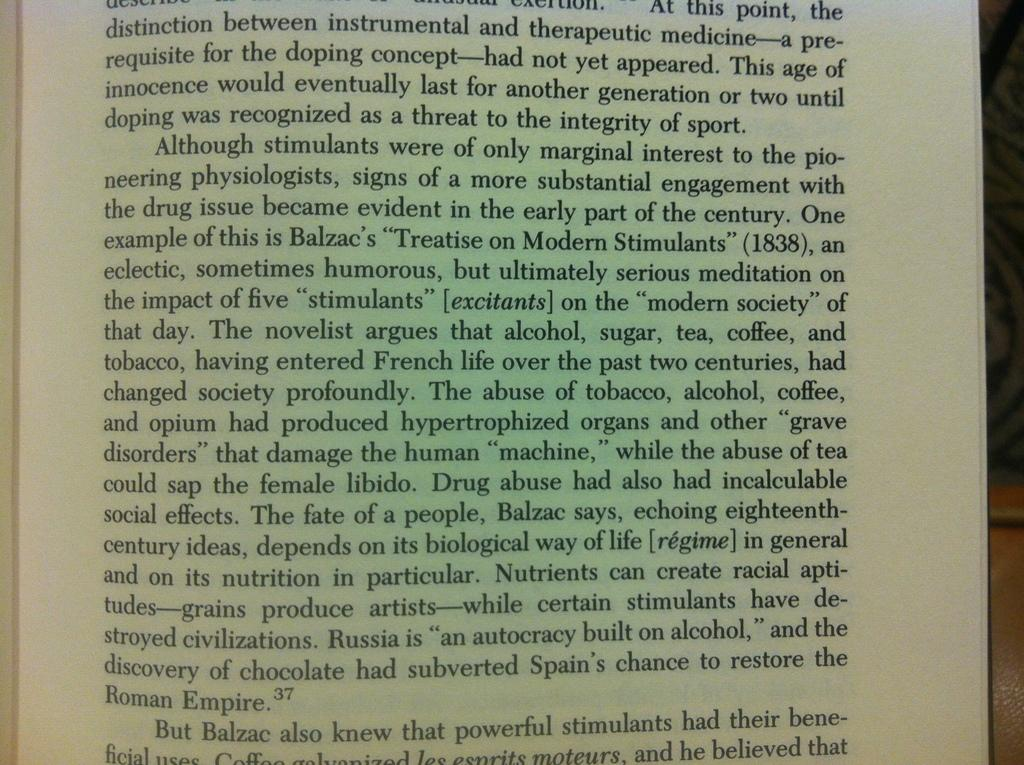What is the main subject in the center of the image? There is a paper with text in the center of the image. What type of leather is being used to make the dog's collar in the image? There is no dog or leather present in the image; it only features a paper with text. 